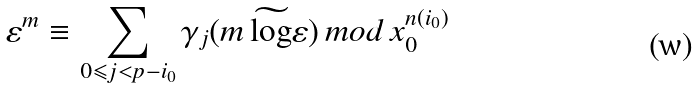<formula> <loc_0><loc_0><loc_500><loc_500>\varepsilon ^ { m } \equiv \sum _ { 0 \leqslant j < p - i _ { 0 } } \gamma _ { j } ( m \, \widetilde { \log } \varepsilon ) \, m o d \, x _ { 0 } ^ { n ( i _ { 0 } ) }</formula> 